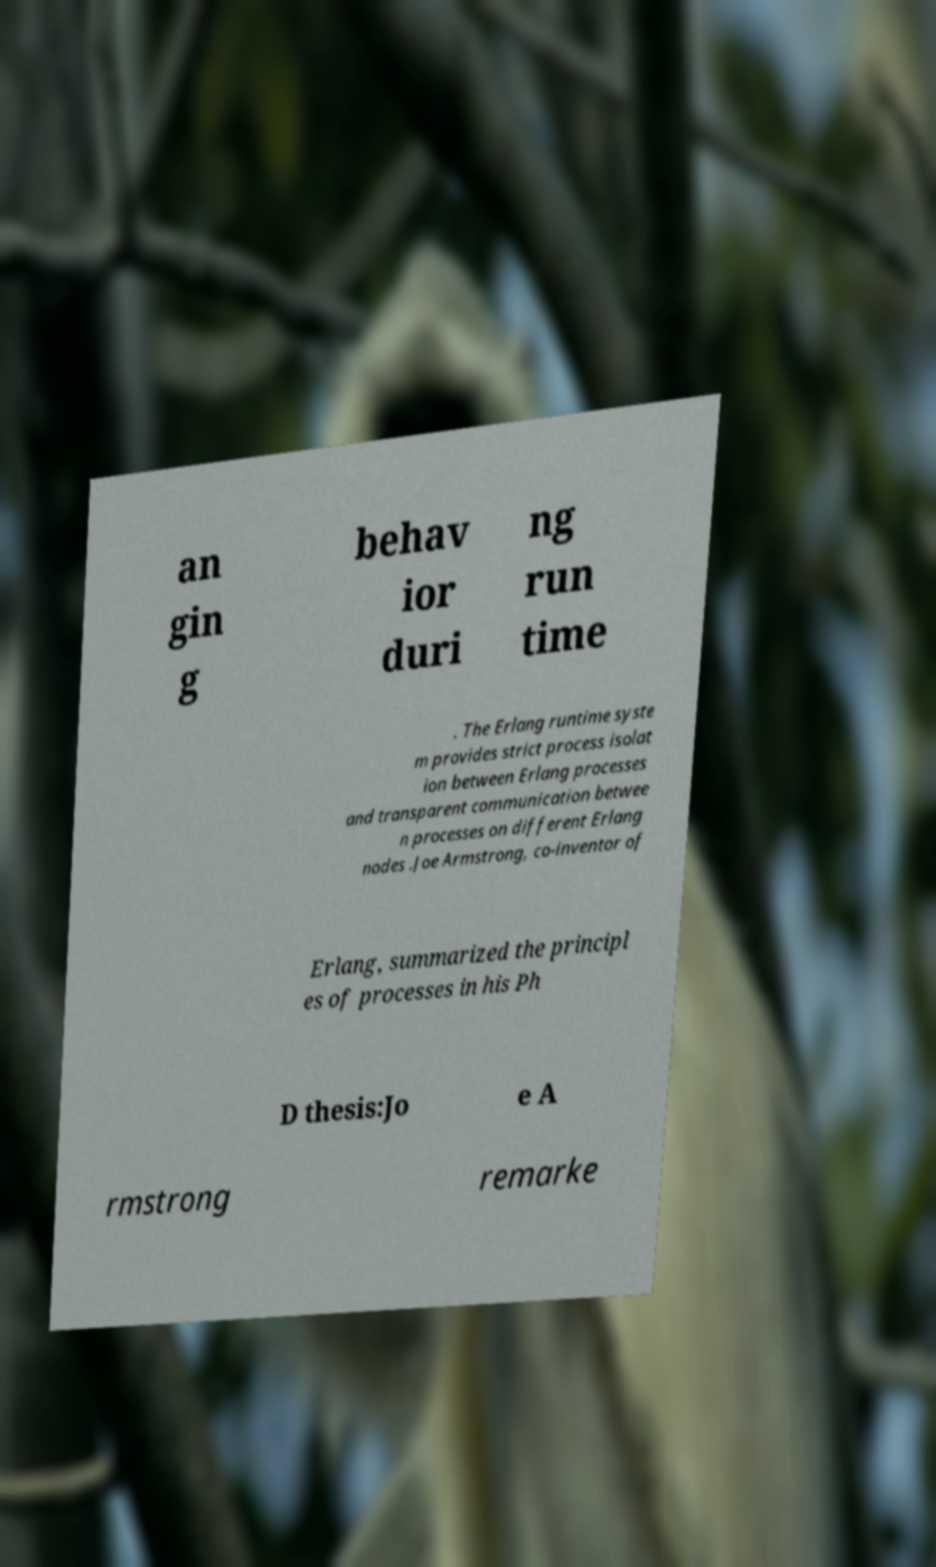Please identify and transcribe the text found in this image. an gin g behav ior duri ng run time . The Erlang runtime syste m provides strict process isolat ion between Erlang processes and transparent communication betwee n processes on different Erlang nodes .Joe Armstrong, co-inventor of Erlang, summarized the principl es of processes in his Ph D thesis:Jo e A rmstrong remarke 